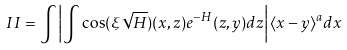Convert formula to latex. <formula><loc_0><loc_0><loc_500><loc_500>I I = \int \left | \int \cos ( \xi \sqrt { H } ) ( x , z ) e ^ { - H } ( z , y ) d z \right | \langle x - y \rangle ^ { a } d x</formula> 